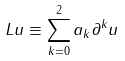Convert formula to latex. <formula><loc_0><loc_0><loc_500><loc_500>L u \equiv \sum _ { k = 0 } ^ { 2 } a _ { k } \partial ^ { k } u</formula> 